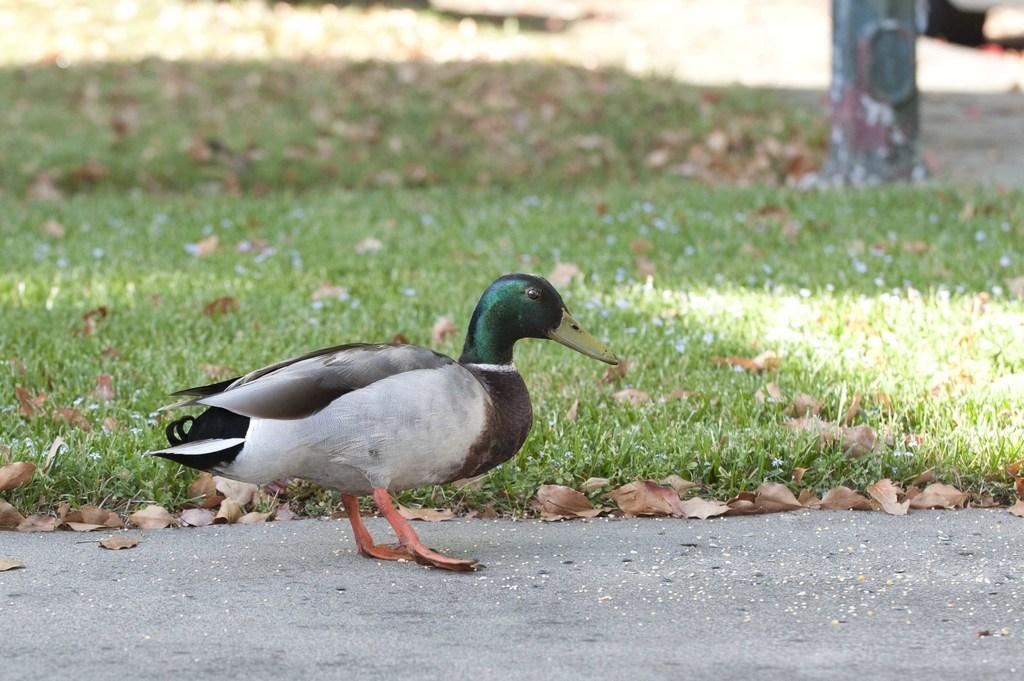Can you describe this image briefly? In this given image, We can see a small garden and dried leaves, road and a duck standing. 